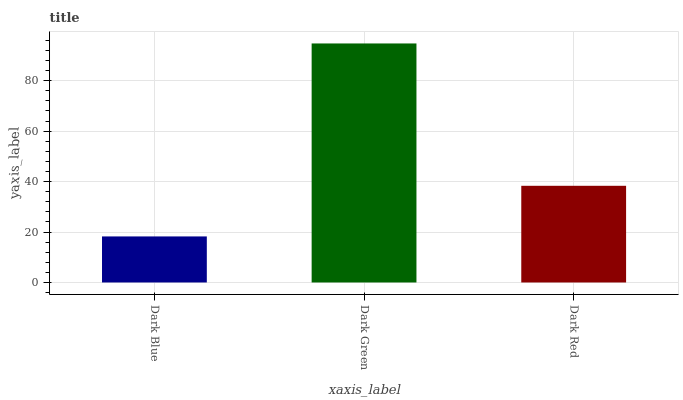Is Dark Blue the minimum?
Answer yes or no. Yes. Is Dark Green the maximum?
Answer yes or no. Yes. Is Dark Red the minimum?
Answer yes or no. No. Is Dark Red the maximum?
Answer yes or no. No. Is Dark Green greater than Dark Red?
Answer yes or no. Yes. Is Dark Red less than Dark Green?
Answer yes or no. Yes. Is Dark Red greater than Dark Green?
Answer yes or no. No. Is Dark Green less than Dark Red?
Answer yes or no. No. Is Dark Red the high median?
Answer yes or no. Yes. Is Dark Red the low median?
Answer yes or no. Yes. Is Dark Blue the high median?
Answer yes or no. No. Is Dark Green the low median?
Answer yes or no. No. 